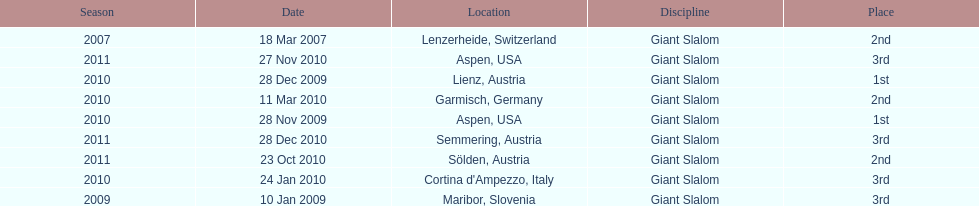What was the finishing place of the last race in december 2010? 3rd. 